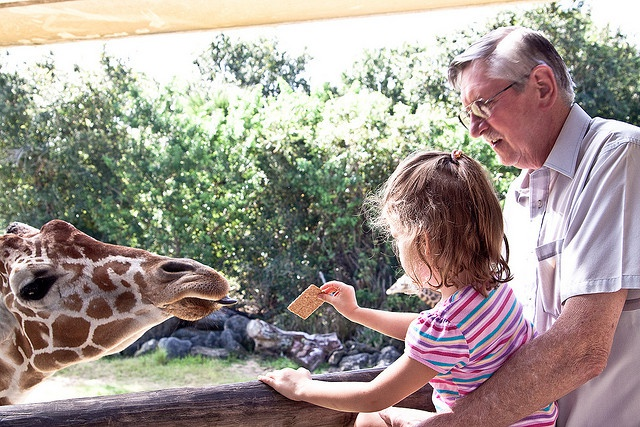Describe the objects in this image and their specific colors. I can see people in white, brown, and darkgray tones, people in white, maroon, brown, and lightpink tones, and giraffe in white, maroon, gray, and darkgray tones in this image. 